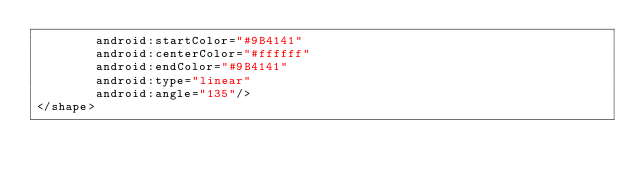<code> <loc_0><loc_0><loc_500><loc_500><_XML_>        android:startColor="#9B4141"
        android:centerColor="#ffffff"
        android:endColor="#9B4141"
        android:type="linear"
        android:angle="135"/>
</shape></code> 